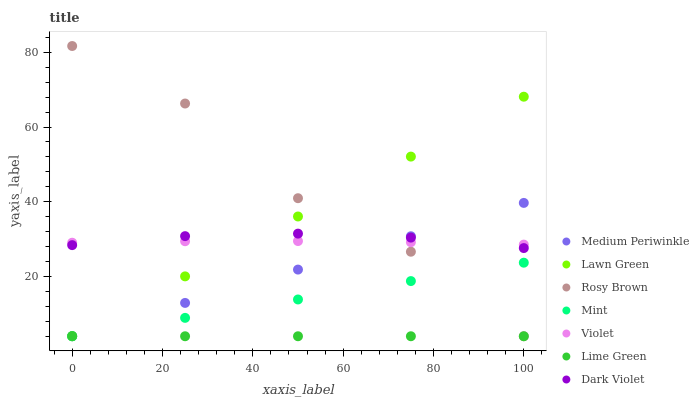Does Lime Green have the minimum area under the curve?
Answer yes or no. Yes. Does Rosy Brown have the maximum area under the curve?
Answer yes or no. Yes. Does Rosy Brown have the minimum area under the curve?
Answer yes or no. No. Does Lime Green have the maximum area under the curve?
Answer yes or no. No. Is Medium Periwinkle the smoothest?
Answer yes or no. Yes. Is Rosy Brown the roughest?
Answer yes or no. Yes. Is Lime Green the smoothest?
Answer yes or no. No. Is Lime Green the roughest?
Answer yes or no. No. Does Lawn Green have the lowest value?
Answer yes or no. Yes. Does Dark Violet have the lowest value?
Answer yes or no. No. Does Rosy Brown have the highest value?
Answer yes or no. Yes. Does Lime Green have the highest value?
Answer yes or no. No. Is Lime Green less than Violet?
Answer yes or no. Yes. Is Dark Violet greater than Lime Green?
Answer yes or no. Yes. Does Medium Periwinkle intersect Rosy Brown?
Answer yes or no. Yes. Is Medium Periwinkle less than Rosy Brown?
Answer yes or no. No. Is Medium Periwinkle greater than Rosy Brown?
Answer yes or no. No. Does Lime Green intersect Violet?
Answer yes or no. No. 